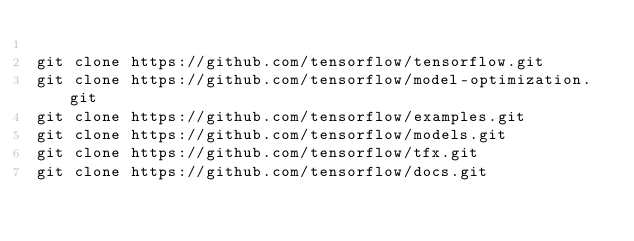<code> <loc_0><loc_0><loc_500><loc_500><_Bash_> 
git clone https://github.com/tensorflow/tensorflow.git
git clone https://github.com/tensorflow/model-optimization.git
git clone https://github.com/tensorflow/examples.git
git clone https://github.com/tensorflow/models.git
git clone https://github.com/tensorflow/tfx.git
git clone https://github.com/tensorflow/docs.git
</code> 